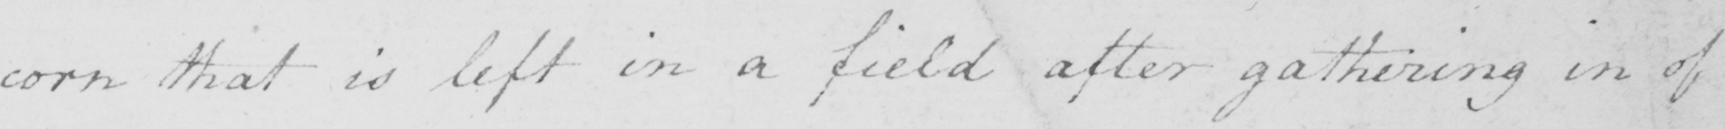Please transcribe the handwritten text in this image. corn that is left in a field after gathering in of 